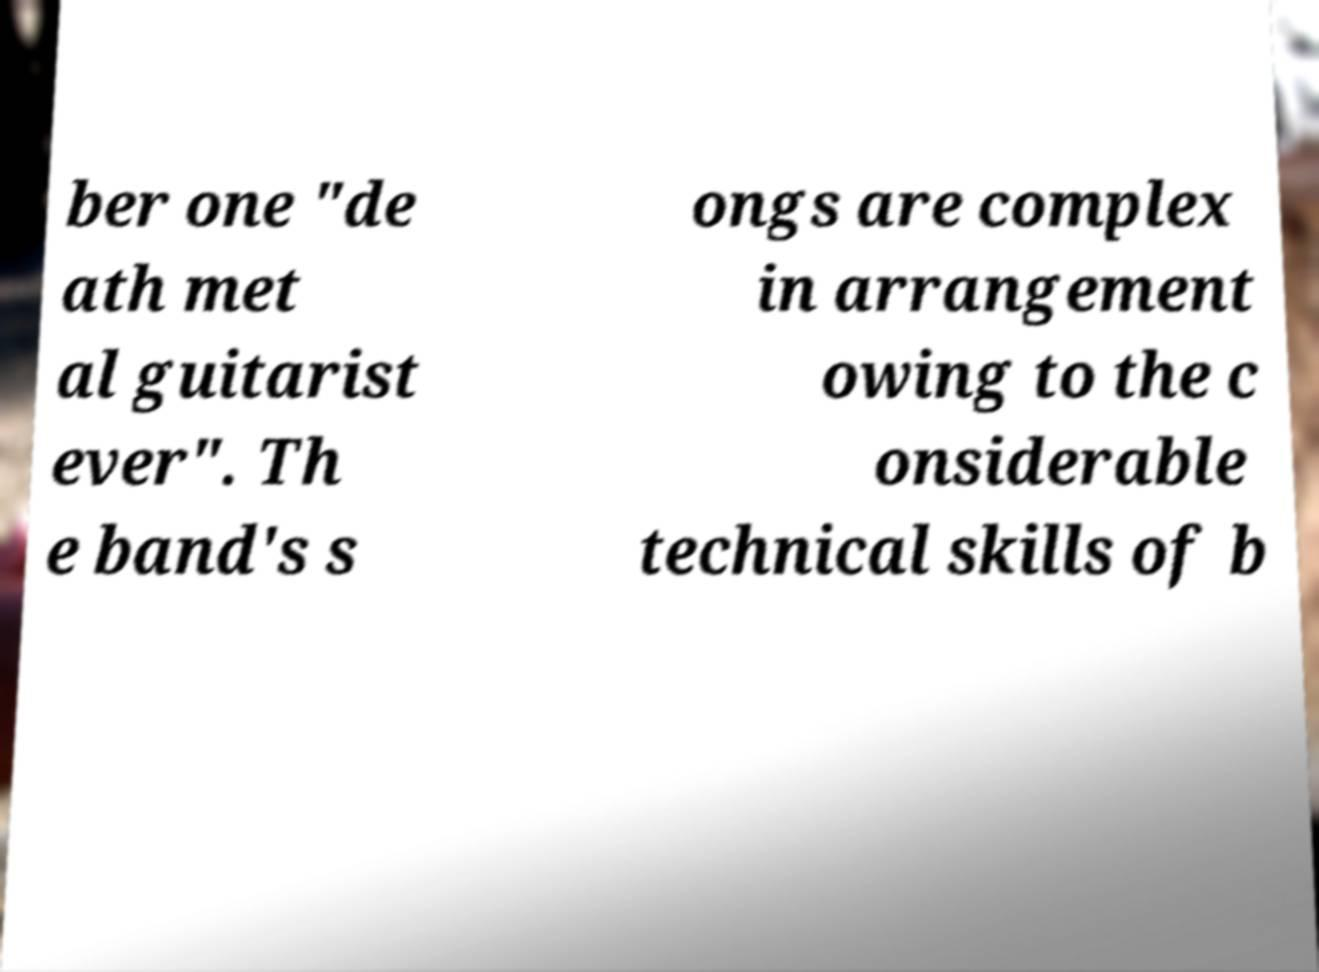For documentation purposes, I need the text within this image transcribed. Could you provide that? ber one "de ath met al guitarist ever". Th e band's s ongs are complex in arrangement owing to the c onsiderable technical skills of b 